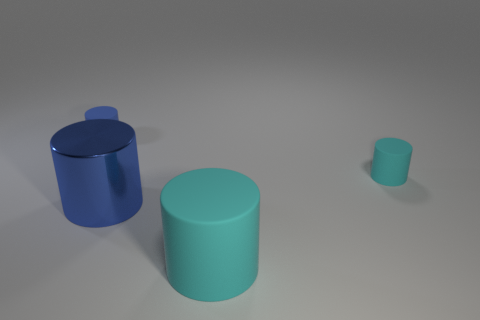Subtract 1 cylinders. How many cylinders are left? 3 Add 1 cylinders. How many objects exist? 5 Add 2 metal things. How many metal things exist? 3 Subtract 0 purple balls. How many objects are left? 4 Subtract all big blue shiny objects. Subtract all purple matte objects. How many objects are left? 3 Add 1 small cyan matte cylinders. How many small cyan matte cylinders are left? 2 